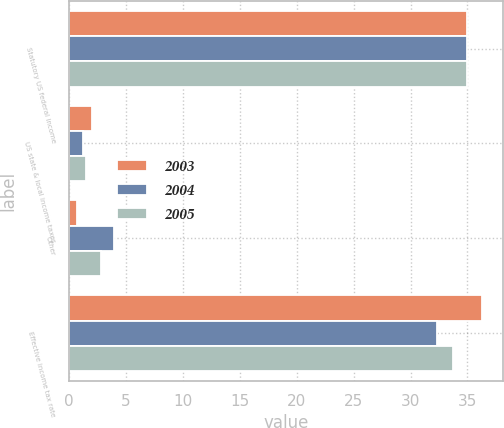<chart> <loc_0><loc_0><loc_500><loc_500><stacked_bar_chart><ecel><fcel>Statutory US federal income<fcel>US state & local income taxes<fcel>Other<fcel>Effective income tax rate<nl><fcel>2003<fcel>35<fcel>2<fcel>0.7<fcel>36.3<nl><fcel>2004<fcel>35<fcel>1.2<fcel>3.9<fcel>32.3<nl><fcel>2005<fcel>35<fcel>1.5<fcel>2.8<fcel>33.7<nl></chart> 